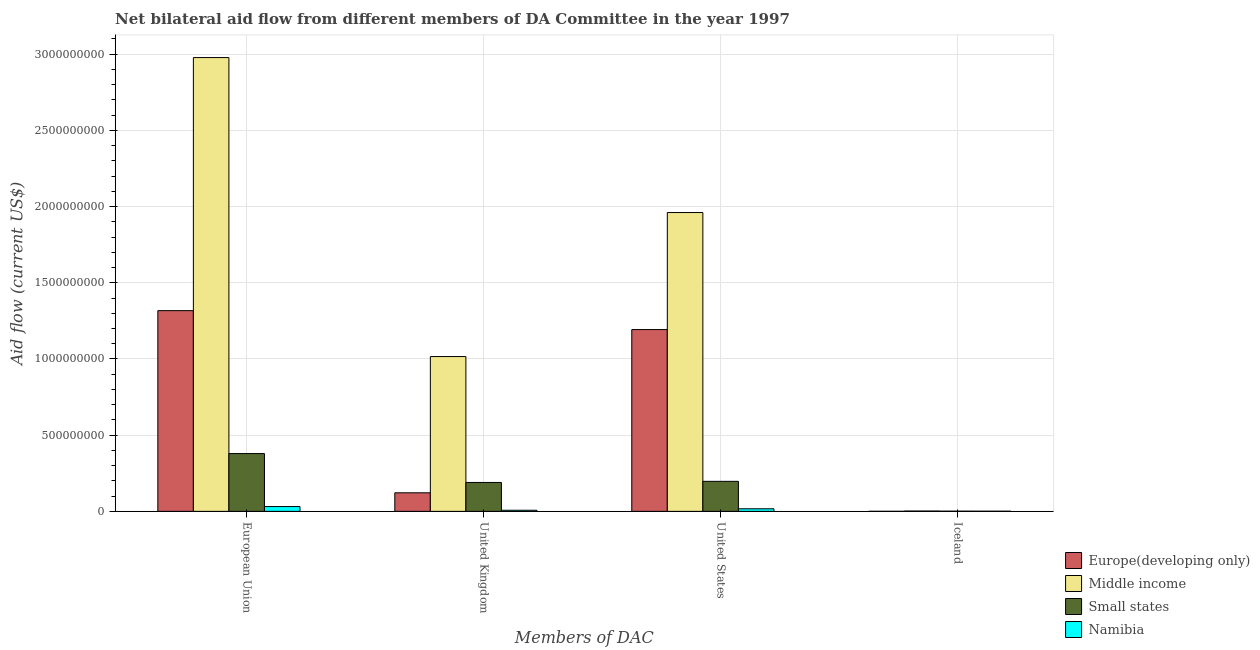Are the number of bars per tick equal to the number of legend labels?
Your answer should be compact. Yes. Are the number of bars on each tick of the X-axis equal?
Your answer should be very brief. Yes. How many bars are there on the 3rd tick from the left?
Make the answer very short. 4. How many bars are there on the 3rd tick from the right?
Make the answer very short. 4. What is the label of the 2nd group of bars from the left?
Make the answer very short. United Kingdom. What is the amount of aid given by iceland in Small states?
Ensure brevity in your answer.  1.30e+06. Across all countries, what is the maximum amount of aid given by us?
Ensure brevity in your answer.  1.96e+09. Across all countries, what is the minimum amount of aid given by eu?
Ensure brevity in your answer.  3.15e+07. In which country was the amount of aid given by uk maximum?
Provide a succinct answer. Middle income. In which country was the amount of aid given by uk minimum?
Offer a very short reply. Namibia. What is the total amount of aid given by eu in the graph?
Offer a very short reply. 4.71e+09. What is the difference between the amount of aid given by eu in Europe(developing only) and that in Middle income?
Your answer should be very brief. -1.66e+09. What is the difference between the amount of aid given by eu in Europe(developing only) and the amount of aid given by iceland in Namibia?
Offer a terse response. 1.32e+09. What is the average amount of aid given by us per country?
Your answer should be very brief. 8.42e+08. What is the difference between the amount of aid given by eu and amount of aid given by iceland in Middle income?
Offer a very short reply. 2.98e+09. What is the ratio of the amount of aid given by us in Namibia to that in Small states?
Keep it short and to the point. 0.09. Is the amount of aid given by eu in Middle income less than that in Small states?
Provide a succinct answer. No. Is the difference between the amount of aid given by iceland in Europe(developing only) and Small states greater than the difference between the amount of aid given by uk in Europe(developing only) and Small states?
Make the answer very short. Yes. What is the difference between the highest and the second highest amount of aid given by uk?
Ensure brevity in your answer.  8.26e+08. What is the difference between the highest and the lowest amount of aid given by us?
Ensure brevity in your answer.  1.94e+09. Is the sum of the amount of aid given by uk in Small states and Middle income greater than the maximum amount of aid given by eu across all countries?
Your answer should be compact. No. Is it the case that in every country, the sum of the amount of aid given by us and amount of aid given by iceland is greater than the sum of amount of aid given by eu and amount of aid given by uk?
Your answer should be compact. No. What does the 1st bar from the left in United Kingdom represents?
Offer a very short reply. Europe(developing only). What does the 1st bar from the right in United Kingdom represents?
Your answer should be very brief. Namibia. Is it the case that in every country, the sum of the amount of aid given by eu and amount of aid given by uk is greater than the amount of aid given by us?
Offer a very short reply. Yes. How many bars are there?
Make the answer very short. 16. Are all the bars in the graph horizontal?
Give a very brief answer. No. Are the values on the major ticks of Y-axis written in scientific E-notation?
Offer a very short reply. No. Does the graph contain any zero values?
Keep it short and to the point. No. Does the graph contain grids?
Give a very brief answer. Yes. How are the legend labels stacked?
Your response must be concise. Vertical. What is the title of the graph?
Give a very brief answer. Net bilateral aid flow from different members of DA Committee in the year 1997. What is the label or title of the X-axis?
Provide a succinct answer. Members of DAC. What is the label or title of the Y-axis?
Offer a terse response. Aid flow (current US$). What is the Aid flow (current US$) of Europe(developing only) in European Union?
Make the answer very short. 1.32e+09. What is the Aid flow (current US$) of Middle income in European Union?
Your answer should be compact. 2.98e+09. What is the Aid flow (current US$) in Small states in European Union?
Offer a terse response. 3.79e+08. What is the Aid flow (current US$) in Namibia in European Union?
Your answer should be very brief. 3.15e+07. What is the Aid flow (current US$) of Europe(developing only) in United Kingdom?
Provide a short and direct response. 1.22e+08. What is the Aid flow (current US$) in Middle income in United Kingdom?
Provide a succinct answer. 1.02e+09. What is the Aid flow (current US$) of Small states in United Kingdom?
Offer a terse response. 1.90e+08. What is the Aid flow (current US$) in Namibia in United Kingdom?
Keep it short and to the point. 7.25e+06. What is the Aid flow (current US$) of Europe(developing only) in United States?
Ensure brevity in your answer.  1.19e+09. What is the Aid flow (current US$) in Middle income in United States?
Your answer should be compact. 1.96e+09. What is the Aid flow (current US$) in Small states in United States?
Give a very brief answer. 1.97e+08. What is the Aid flow (current US$) of Namibia in United States?
Keep it short and to the point. 1.70e+07. What is the Aid flow (current US$) of Europe(developing only) in Iceland?
Offer a very short reply. 3.80e+05. What is the Aid flow (current US$) in Middle income in Iceland?
Provide a short and direct response. 2.18e+06. What is the Aid flow (current US$) of Small states in Iceland?
Give a very brief answer. 1.30e+06. What is the Aid flow (current US$) of Namibia in Iceland?
Keep it short and to the point. 1.08e+06. Across all Members of DAC, what is the maximum Aid flow (current US$) in Europe(developing only)?
Ensure brevity in your answer.  1.32e+09. Across all Members of DAC, what is the maximum Aid flow (current US$) of Middle income?
Provide a short and direct response. 2.98e+09. Across all Members of DAC, what is the maximum Aid flow (current US$) of Small states?
Make the answer very short. 3.79e+08. Across all Members of DAC, what is the maximum Aid flow (current US$) in Namibia?
Your answer should be compact. 3.15e+07. Across all Members of DAC, what is the minimum Aid flow (current US$) of Europe(developing only)?
Give a very brief answer. 3.80e+05. Across all Members of DAC, what is the minimum Aid flow (current US$) in Middle income?
Make the answer very short. 2.18e+06. Across all Members of DAC, what is the minimum Aid flow (current US$) in Small states?
Offer a terse response. 1.30e+06. Across all Members of DAC, what is the minimum Aid flow (current US$) of Namibia?
Ensure brevity in your answer.  1.08e+06. What is the total Aid flow (current US$) in Europe(developing only) in the graph?
Offer a terse response. 2.63e+09. What is the total Aid flow (current US$) in Middle income in the graph?
Your answer should be compact. 5.96e+09. What is the total Aid flow (current US$) in Small states in the graph?
Provide a short and direct response. 7.67e+08. What is the total Aid flow (current US$) of Namibia in the graph?
Offer a very short reply. 5.68e+07. What is the difference between the Aid flow (current US$) of Europe(developing only) in European Union and that in United Kingdom?
Give a very brief answer. 1.20e+09. What is the difference between the Aid flow (current US$) in Middle income in European Union and that in United Kingdom?
Give a very brief answer. 1.96e+09. What is the difference between the Aid flow (current US$) in Small states in European Union and that in United Kingdom?
Your answer should be compact. 1.90e+08. What is the difference between the Aid flow (current US$) of Namibia in European Union and that in United Kingdom?
Provide a short and direct response. 2.42e+07. What is the difference between the Aid flow (current US$) in Europe(developing only) in European Union and that in United States?
Offer a very short reply. 1.24e+08. What is the difference between the Aid flow (current US$) of Middle income in European Union and that in United States?
Ensure brevity in your answer.  1.02e+09. What is the difference between the Aid flow (current US$) in Small states in European Union and that in United States?
Keep it short and to the point. 1.82e+08. What is the difference between the Aid flow (current US$) in Namibia in European Union and that in United States?
Make the answer very short. 1.45e+07. What is the difference between the Aid flow (current US$) in Europe(developing only) in European Union and that in Iceland?
Your answer should be compact. 1.32e+09. What is the difference between the Aid flow (current US$) in Middle income in European Union and that in Iceland?
Offer a terse response. 2.98e+09. What is the difference between the Aid flow (current US$) in Small states in European Union and that in Iceland?
Offer a very short reply. 3.78e+08. What is the difference between the Aid flow (current US$) of Namibia in European Union and that in Iceland?
Your answer should be compact. 3.04e+07. What is the difference between the Aid flow (current US$) in Europe(developing only) in United Kingdom and that in United States?
Provide a succinct answer. -1.07e+09. What is the difference between the Aid flow (current US$) in Middle income in United Kingdom and that in United States?
Give a very brief answer. -9.45e+08. What is the difference between the Aid flow (current US$) in Small states in United Kingdom and that in United States?
Give a very brief answer. -7.34e+06. What is the difference between the Aid flow (current US$) of Namibia in United Kingdom and that in United States?
Make the answer very short. -9.75e+06. What is the difference between the Aid flow (current US$) in Europe(developing only) in United Kingdom and that in Iceland?
Your answer should be compact. 1.21e+08. What is the difference between the Aid flow (current US$) of Middle income in United Kingdom and that in Iceland?
Provide a short and direct response. 1.01e+09. What is the difference between the Aid flow (current US$) of Small states in United Kingdom and that in Iceland?
Ensure brevity in your answer.  1.88e+08. What is the difference between the Aid flow (current US$) in Namibia in United Kingdom and that in Iceland?
Offer a very short reply. 6.17e+06. What is the difference between the Aid flow (current US$) of Europe(developing only) in United States and that in Iceland?
Offer a terse response. 1.19e+09. What is the difference between the Aid flow (current US$) in Middle income in United States and that in Iceland?
Offer a terse response. 1.96e+09. What is the difference between the Aid flow (current US$) of Small states in United States and that in Iceland?
Your answer should be compact. 1.96e+08. What is the difference between the Aid flow (current US$) in Namibia in United States and that in Iceland?
Your answer should be compact. 1.59e+07. What is the difference between the Aid flow (current US$) in Europe(developing only) in European Union and the Aid flow (current US$) in Middle income in United Kingdom?
Give a very brief answer. 3.01e+08. What is the difference between the Aid flow (current US$) of Europe(developing only) in European Union and the Aid flow (current US$) of Small states in United Kingdom?
Offer a terse response. 1.13e+09. What is the difference between the Aid flow (current US$) of Europe(developing only) in European Union and the Aid flow (current US$) of Namibia in United Kingdom?
Give a very brief answer. 1.31e+09. What is the difference between the Aid flow (current US$) in Middle income in European Union and the Aid flow (current US$) in Small states in United Kingdom?
Ensure brevity in your answer.  2.79e+09. What is the difference between the Aid flow (current US$) in Middle income in European Union and the Aid flow (current US$) in Namibia in United Kingdom?
Keep it short and to the point. 2.97e+09. What is the difference between the Aid flow (current US$) of Small states in European Union and the Aid flow (current US$) of Namibia in United Kingdom?
Keep it short and to the point. 3.72e+08. What is the difference between the Aid flow (current US$) of Europe(developing only) in European Union and the Aid flow (current US$) of Middle income in United States?
Make the answer very short. -6.44e+08. What is the difference between the Aid flow (current US$) in Europe(developing only) in European Union and the Aid flow (current US$) in Small states in United States?
Make the answer very short. 1.12e+09. What is the difference between the Aid flow (current US$) of Europe(developing only) in European Union and the Aid flow (current US$) of Namibia in United States?
Make the answer very short. 1.30e+09. What is the difference between the Aid flow (current US$) in Middle income in European Union and the Aid flow (current US$) in Small states in United States?
Provide a succinct answer. 2.78e+09. What is the difference between the Aid flow (current US$) of Middle income in European Union and the Aid flow (current US$) of Namibia in United States?
Provide a succinct answer. 2.96e+09. What is the difference between the Aid flow (current US$) in Small states in European Union and the Aid flow (current US$) in Namibia in United States?
Your answer should be very brief. 3.62e+08. What is the difference between the Aid flow (current US$) in Europe(developing only) in European Union and the Aid flow (current US$) in Middle income in Iceland?
Your answer should be very brief. 1.31e+09. What is the difference between the Aid flow (current US$) in Europe(developing only) in European Union and the Aid flow (current US$) in Small states in Iceland?
Ensure brevity in your answer.  1.32e+09. What is the difference between the Aid flow (current US$) in Europe(developing only) in European Union and the Aid flow (current US$) in Namibia in Iceland?
Your answer should be very brief. 1.32e+09. What is the difference between the Aid flow (current US$) of Middle income in European Union and the Aid flow (current US$) of Small states in Iceland?
Offer a very short reply. 2.98e+09. What is the difference between the Aid flow (current US$) in Middle income in European Union and the Aid flow (current US$) in Namibia in Iceland?
Provide a succinct answer. 2.98e+09. What is the difference between the Aid flow (current US$) of Small states in European Union and the Aid flow (current US$) of Namibia in Iceland?
Make the answer very short. 3.78e+08. What is the difference between the Aid flow (current US$) of Europe(developing only) in United Kingdom and the Aid flow (current US$) of Middle income in United States?
Provide a short and direct response. -1.84e+09. What is the difference between the Aid flow (current US$) of Europe(developing only) in United Kingdom and the Aid flow (current US$) of Small states in United States?
Your response must be concise. -7.52e+07. What is the difference between the Aid flow (current US$) in Europe(developing only) in United Kingdom and the Aid flow (current US$) in Namibia in United States?
Ensure brevity in your answer.  1.05e+08. What is the difference between the Aid flow (current US$) of Middle income in United Kingdom and the Aid flow (current US$) of Small states in United States?
Your response must be concise. 8.19e+08. What is the difference between the Aid flow (current US$) in Middle income in United Kingdom and the Aid flow (current US$) in Namibia in United States?
Your answer should be very brief. 9.99e+08. What is the difference between the Aid flow (current US$) of Small states in United Kingdom and the Aid flow (current US$) of Namibia in United States?
Your answer should be compact. 1.73e+08. What is the difference between the Aid flow (current US$) of Europe(developing only) in United Kingdom and the Aid flow (current US$) of Middle income in Iceland?
Keep it short and to the point. 1.20e+08. What is the difference between the Aid flow (current US$) of Europe(developing only) in United Kingdom and the Aid flow (current US$) of Small states in Iceland?
Ensure brevity in your answer.  1.21e+08. What is the difference between the Aid flow (current US$) of Europe(developing only) in United Kingdom and the Aid flow (current US$) of Namibia in Iceland?
Provide a short and direct response. 1.21e+08. What is the difference between the Aid flow (current US$) of Middle income in United Kingdom and the Aid flow (current US$) of Small states in Iceland?
Your answer should be compact. 1.01e+09. What is the difference between the Aid flow (current US$) of Middle income in United Kingdom and the Aid flow (current US$) of Namibia in Iceland?
Provide a succinct answer. 1.01e+09. What is the difference between the Aid flow (current US$) of Small states in United Kingdom and the Aid flow (current US$) of Namibia in Iceland?
Offer a terse response. 1.89e+08. What is the difference between the Aid flow (current US$) in Europe(developing only) in United States and the Aid flow (current US$) in Middle income in Iceland?
Keep it short and to the point. 1.19e+09. What is the difference between the Aid flow (current US$) in Europe(developing only) in United States and the Aid flow (current US$) in Small states in Iceland?
Ensure brevity in your answer.  1.19e+09. What is the difference between the Aid flow (current US$) in Europe(developing only) in United States and the Aid flow (current US$) in Namibia in Iceland?
Make the answer very short. 1.19e+09. What is the difference between the Aid flow (current US$) in Middle income in United States and the Aid flow (current US$) in Small states in Iceland?
Keep it short and to the point. 1.96e+09. What is the difference between the Aid flow (current US$) of Middle income in United States and the Aid flow (current US$) of Namibia in Iceland?
Your response must be concise. 1.96e+09. What is the difference between the Aid flow (current US$) in Small states in United States and the Aid flow (current US$) in Namibia in Iceland?
Keep it short and to the point. 1.96e+08. What is the average Aid flow (current US$) of Europe(developing only) per Members of DAC?
Keep it short and to the point. 6.58e+08. What is the average Aid flow (current US$) in Middle income per Members of DAC?
Offer a terse response. 1.49e+09. What is the average Aid flow (current US$) in Small states per Members of DAC?
Your answer should be very brief. 1.92e+08. What is the average Aid flow (current US$) in Namibia per Members of DAC?
Provide a succinct answer. 1.42e+07. What is the difference between the Aid flow (current US$) of Europe(developing only) and Aid flow (current US$) of Middle income in European Union?
Your response must be concise. -1.66e+09. What is the difference between the Aid flow (current US$) of Europe(developing only) and Aid flow (current US$) of Small states in European Union?
Give a very brief answer. 9.38e+08. What is the difference between the Aid flow (current US$) in Europe(developing only) and Aid flow (current US$) in Namibia in European Union?
Your answer should be very brief. 1.29e+09. What is the difference between the Aid flow (current US$) in Middle income and Aid flow (current US$) in Small states in European Union?
Keep it short and to the point. 2.60e+09. What is the difference between the Aid flow (current US$) in Middle income and Aid flow (current US$) in Namibia in European Union?
Make the answer very short. 2.95e+09. What is the difference between the Aid flow (current US$) in Small states and Aid flow (current US$) in Namibia in European Union?
Keep it short and to the point. 3.48e+08. What is the difference between the Aid flow (current US$) in Europe(developing only) and Aid flow (current US$) in Middle income in United Kingdom?
Your answer should be compact. -8.94e+08. What is the difference between the Aid flow (current US$) of Europe(developing only) and Aid flow (current US$) of Small states in United Kingdom?
Keep it short and to the point. -6.78e+07. What is the difference between the Aid flow (current US$) of Europe(developing only) and Aid flow (current US$) of Namibia in United Kingdom?
Provide a succinct answer. 1.15e+08. What is the difference between the Aid flow (current US$) in Middle income and Aid flow (current US$) in Small states in United Kingdom?
Your answer should be compact. 8.26e+08. What is the difference between the Aid flow (current US$) of Middle income and Aid flow (current US$) of Namibia in United Kingdom?
Offer a terse response. 1.01e+09. What is the difference between the Aid flow (current US$) of Small states and Aid flow (current US$) of Namibia in United Kingdom?
Your answer should be very brief. 1.82e+08. What is the difference between the Aid flow (current US$) of Europe(developing only) and Aid flow (current US$) of Middle income in United States?
Make the answer very short. -7.68e+08. What is the difference between the Aid flow (current US$) in Europe(developing only) and Aid flow (current US$) in Small states in United States?
Your response must be concise. 9.96e+08. What is the difference between the Aid flow (current US$) in Europe(developing only) and Aid flow (current US$) in Namibia in United States?
Offer a very short reply. 1.18e+09. What is the difference between the Aid flow (current US$) in Middle income and Aid flow (current US$) in Small states in United States?
Offer a very short reply. 1.76e+09. What is the difference between the Aid flow (current US$) of Middle income and Aid flow (current US$) of Namibia in United States?
Keep it short and to the point. 1.94e+09. What is the difference between the Aid flow (current US$) in Small states and Aid flow (current US$) in Namibia in United States?
Provide a succinct answer. 1.80e+08. What is the difference between the Aid flow (current US$) in Europe(developing only) and Aid flow (current US$) in Middle income in Iceland?
Your answer should be compact. -1.80e+06. What is the difference between the Aid flow (current US$) in Europe(developing only) and Aid flow (current US$) in Small states in Iceland?
Make the answer very short. -9.20e+05. What is the difference between the Aid flow (current US$) in Europe(developing only) and Aid flow (current US$) in Namibia in Iceland?
Your answer should be very brief. -7.00e+05. What is the difference between the Aid flow (current US$) in Middle income and Aid flow (current US$) in Small states in Iceland?
Give a very brief answer. 8.80e+05. What is the difference between the Aid flow (current US$) in Middle income and Aid flow (current US$) in Namibia in Iceland?
Give a very brief answer. 1.10e+06. What is the ratio of the Aid flow (current US$) in Europe(developing only) in European Union to that in United Kingdom?
Provide a short and direct response. 10.81. What is the ratio of the Aid flow (current US$) in Middle income in European Union to that in United Kingdom?
Provide a short and direct response. 2.93. What is the ratio of the Aid flow (current US$) of Small states in European Union to that in United Kingdom?
Your answer should be very brief. 2. What is the ratio of the Aid flow (current US$) in Namibia in European Union to that in United Kingdom?
Ensure brevity in your answer.  4.34. What is the ratio of the Aid flow (current US$) of Europe(developing only) in European Union to that in United States?
Offer a very short reply. 1.1. What is the ratio of the Aid flow (current US$) in Middle income in European Union to that in United States?
Ensure brevity in your answer.  1.52. What is the ratio of the Aid flow (current US$) in Small states in European Union to that in United States?
Your response must be concise. 1.93. What is the ratio of the Aid flow (current US$) in Namibia in European Union to that in United States?
Your response must be concise. 1.85. What is the ratio of the Aid flow (current US$) in Europe(developing only) in European Union to that in Iceland?
Your answer should be very brief. 3466.24. What is the ratio of the Aid flow (current US$) of Middle income in European Union to that in Iceland?
Keep it short and to the point. 1366.02. What is the ratio of the Aid flow (current US$) of Small states in European Union to that in Iceland?
Your answer should be very brief. 291.83. What is the ratio of the Aid flow (current US$) in Namibia in European Union to that in Iceland?
Keep it short and to the point. 29.15. What is the ratio of the Aid flow (current US$) in Europe(developing only) in United Kingdom to that in United States?
Offer a terse response. 0.1. What is the ratio of the Aid flow (current US$) of Middle income in United Kingdom to that in United States?
Provide a short and direct response. 0.52. What is the ratio of the Aid flow (current US$) of Small states in United Kingdom to that in United States?
Your answer should be compact. 0.96. What is the ratio of the Aid flow (current US$) in Namibia in United Kingdom to that in United States?
Ensure brevity in your answer.  0.43. What is the ratio of the Aid flow (current US$) in Europe(developing only) in United Kingdom to that in Iceland?
Offer a very short reply. 320.55. What is the ratio of the Aid flow (current US$) in Middle income in United Kingdom to that in Iceland?
Ensure brevity in your answer.  466.02. What is the ratio of the Aid flow (current US$) of Small states in United Kingdom to that in Iceland?
Offer a very short reply. 145.89. What is the ratio of the Aid flow (current US$) of Namibia in United Kingdom to that in Iceland?
Your answer should be compact. 6.71. What is the ratio of the Aid flow (current US$) in Europe(developing only) in United States to that in Iceland?
Offer a very short reply. 3139.47. What is the ratio of the Aid flow (current US$) in Middle income in United States to that in Iceland?
Your response must be concise. 899.54. What is the ratio of the Aid flow (current US$) of Small states in United States to that in Iceland?
Make the answer very short. 151.54. What is the ratio of the Aid flow (current US$) of Namibia in United States to that in Iceland?
Provide a succinct answer. 15.74. What is the difference between the highest and the second highest Aid flow (current US$) of Europe(developing only)?
Provide a short and direct response. 1.24e+08. What is the difference between the highest and the second highest Aid flow (current US$) in Middle income?
Offer a very short reply. 1.02e+09. What is the difference between the highest and the second highest Aid flow (current US$) in Small states?
Make the answer very short. 1.82e+08. What is the difference between the highest and the second highest Aid flow (current US$) of Namibia?
Your answer should be very brief. 1.45e+07. What is the difference between the highest and the lowest Aid flow (current US$) in Europe(developing only)?
Your answer should be compact. 1.32e+09. What is the difference between the highest and the lowest Aid flow (current US$) in Middle income?
Offer a very short reply. 2.98e+09. What is the difference between the highest and the lowest Aid flow (current US$) in Small states?
Provide a short and direct response. 3.78e+08. What is the difference between the highest and the lowest Aid flow (current US$) of Namibia?
Offer a terse response. 3.04e+07. 